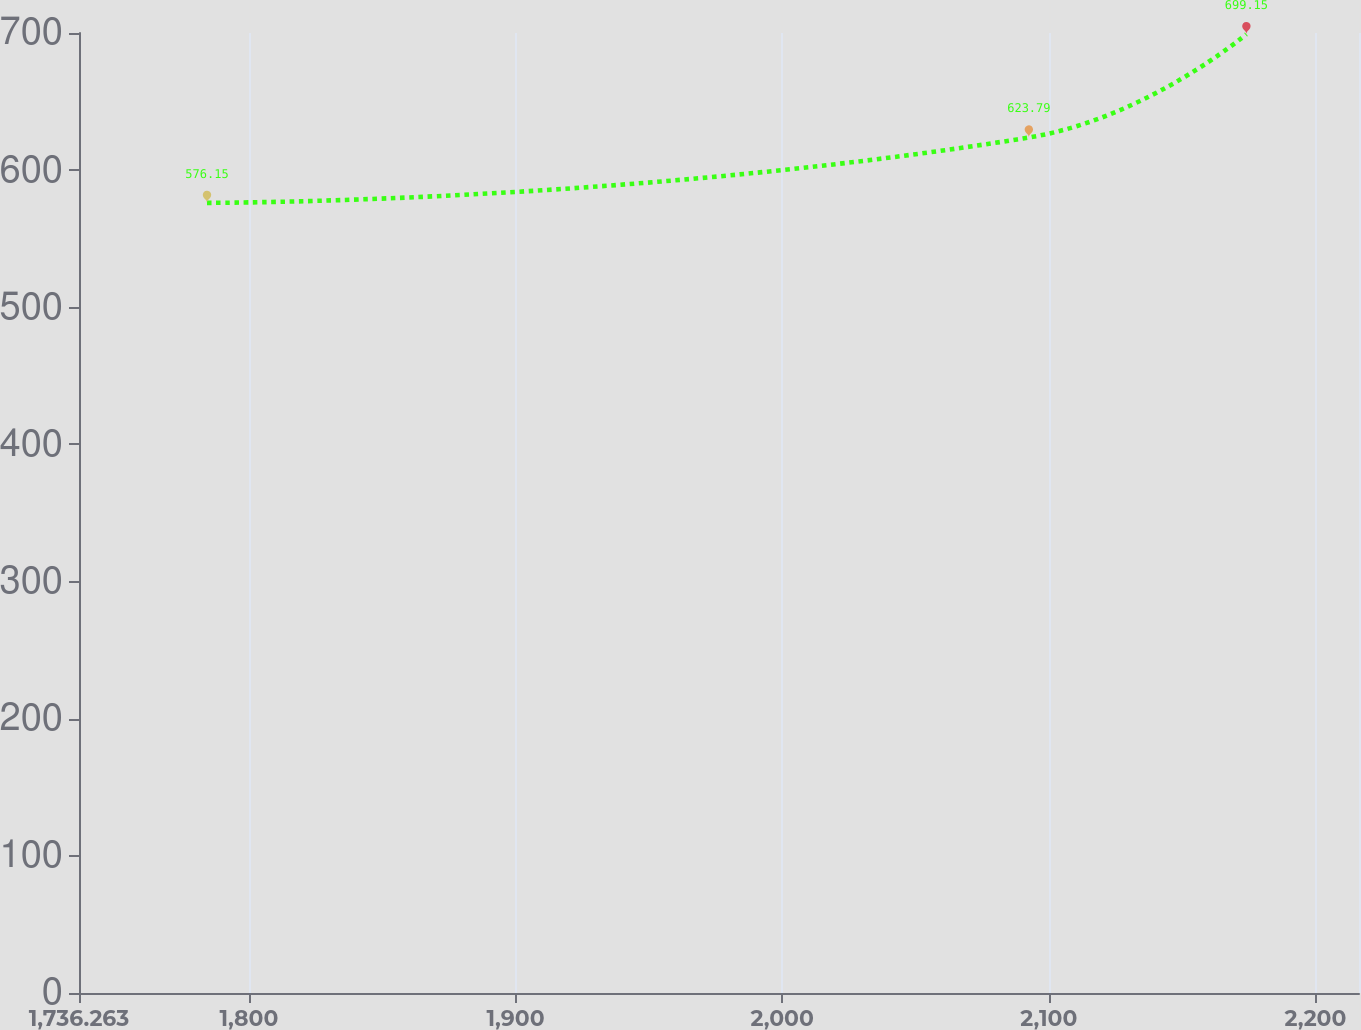Convert chart to OTSL. <chart><loc_0><loc_0><loc_500><loc_500><line_chart><ecel><fcel>Operating Premises Leases<nl><fcel>1784.27<fcel>576.15<nl><fcel>2092.51<fcel>623.79<nl><fcel>2174.1<fcel>699.15<nl><fcel>2219.22<fcel>597.74<nl><fcel>2264.34<fcel>483.3<nl></chart> 